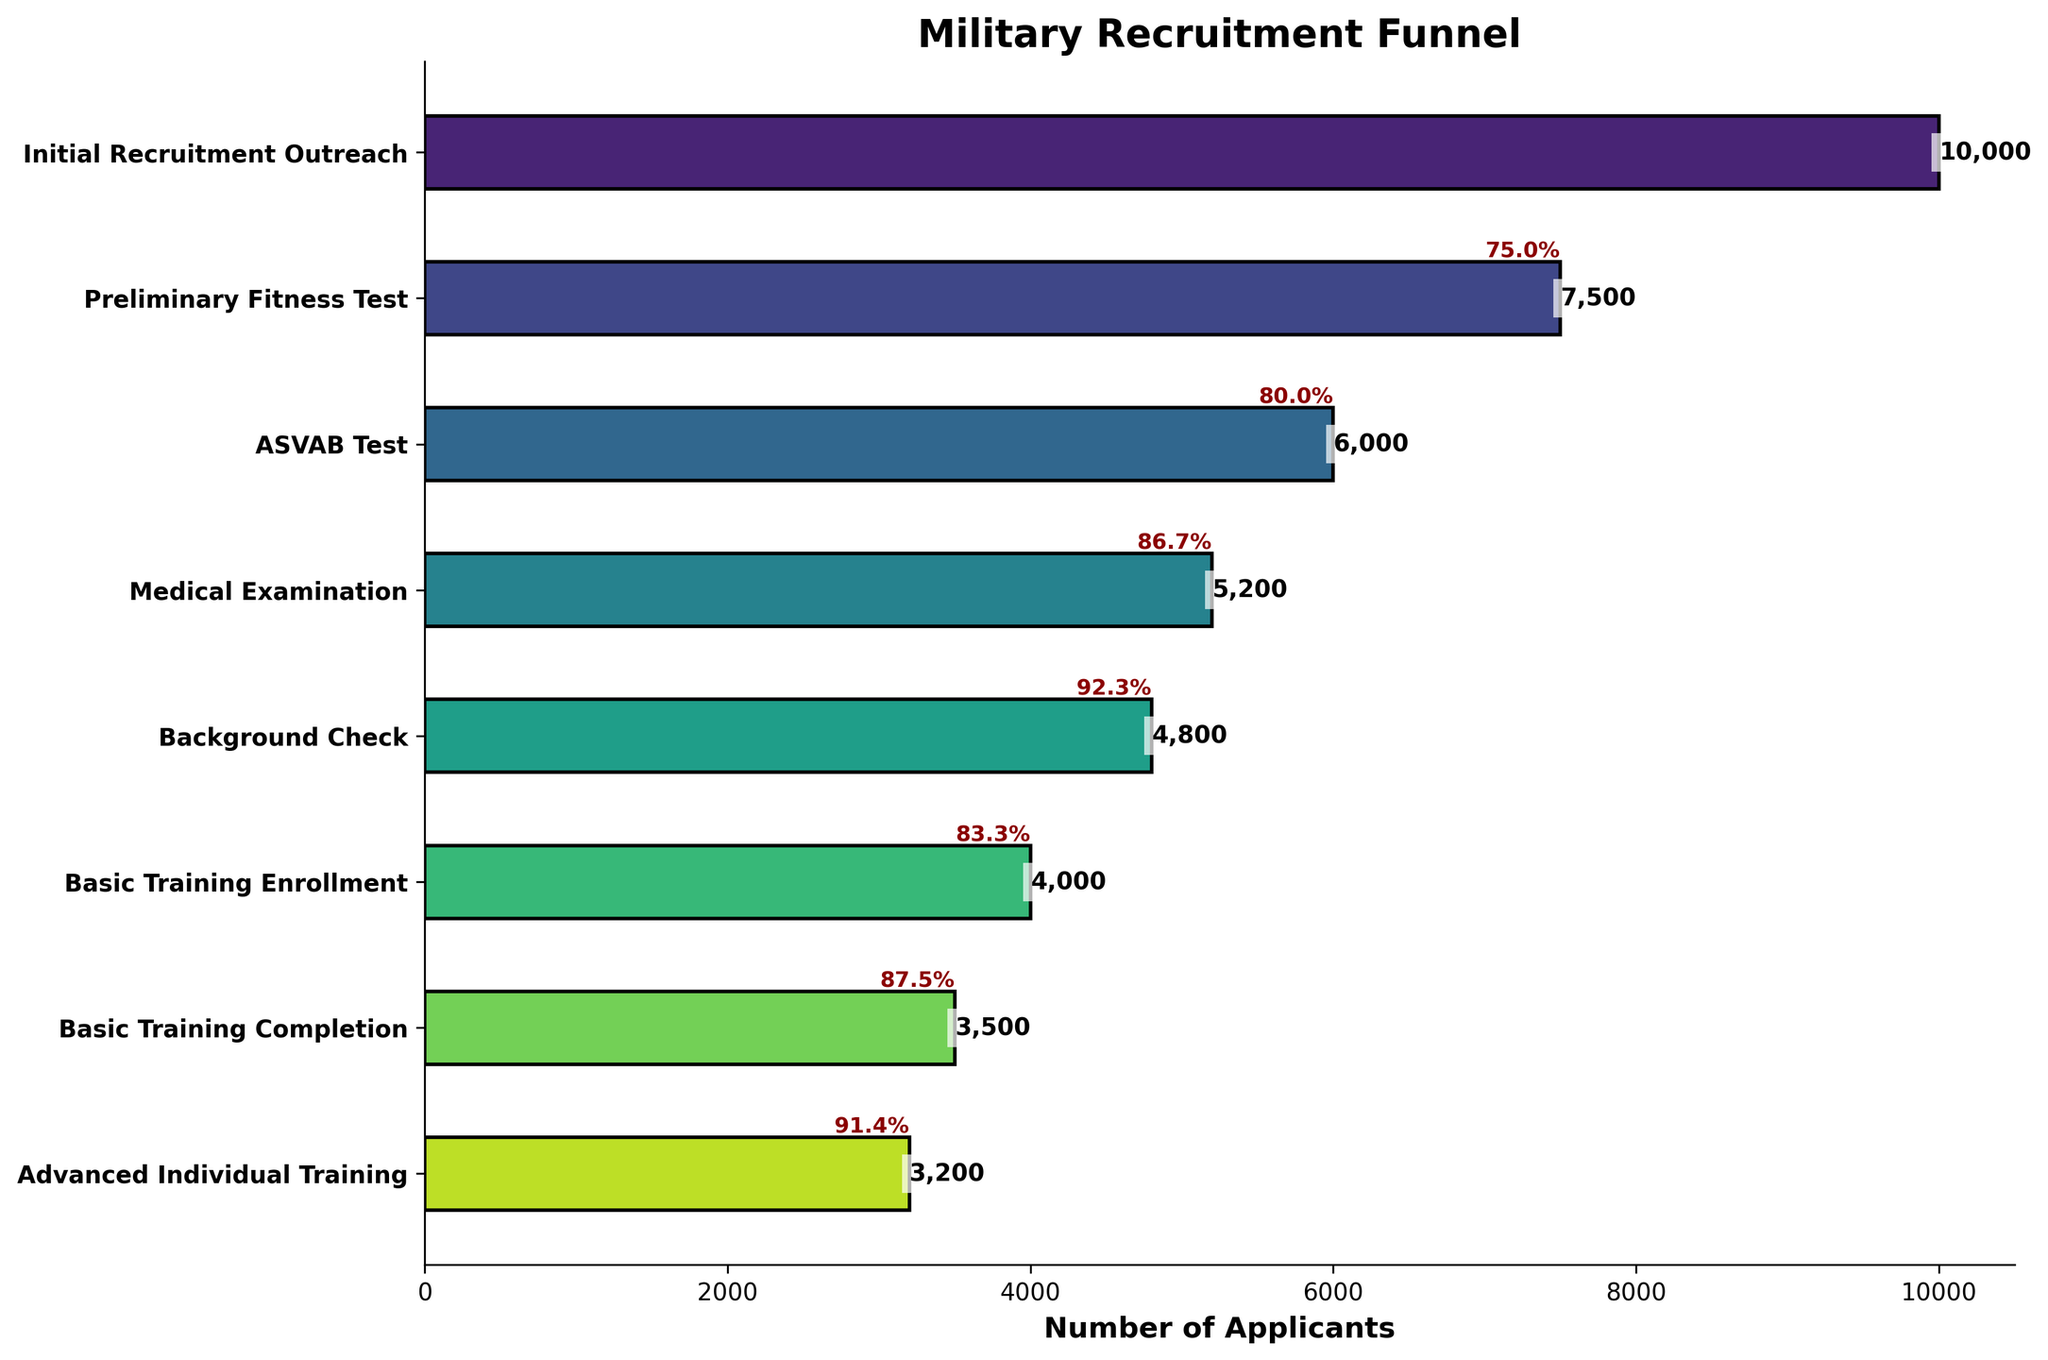What is the title of the chart? The title of the chart is typically found at the top and is often set in a larger or bold font. In this chart, it's "Military Recruitment Funnel."
Answer: Military Recruitment Funnel How many stages are represented in the funnel chart? The number of stages can be counted by the bars on the vertical axis of the chart. By counting each bar, we find there are 8 stages.
Answer: 8 What is the number of applicants at the Initial Recruitment Outreach stage? The number of applicants at each stage is displayed next to the bars. For the Initial Recruitment Outreach stage, the number is 10,000.
Answer: 10,000 How many applicants pass from the Medical Examination stage to the Background Check stage? The number of applicants who progress can be found by subtracting the Background Check stage count (4,800) from the Medical Examination stage count (5,200).
Answer: 400 Which stage has the lowest number of applicants? To find the stage with the lowest number of applicants, compare the numbers next to each bar. The Advanced Individual Training stage has the lowest at 3,200.
Answer: Advanced Individual Training What is the drop rate percentage between the Preliminary Fitness Test and the ASVAB Test stages? The drop rate is found by calculating the difference between the counts and then dividing by the initial count. \[((7500 - 6000)/7500) * 100 = 20\%
Answer: 20% By how much does the number of applicants decrease from Basic Training Enrollment to Basic Training Completion? Subtract the number at Basic Training Completion (3,500) from Basic Training Enrollment (4,000).
Answer: 500 What stage sees the largest drop in number of applicants? To find this, compare the differences between sequential stages. The stage from Preliminary Fitness Test (7,500) to ASVAB Test (6,000) has the largest drop of 1,500 applicants.
Answer: Preliminary Fitness Test to ASVAB Test What is the percentage of applicants that complete Basic Training compared to those who enroll in it? Calculate the ratio of Basic Training Completion (3,500) to Basic Training Enrollment (4,000) and multiply by 100. \((3,500/4,000) * 100 = 87.5\%
Answer: 87.5% How many applicants are lost from the start of the process to the end? Subtract the number of applicants in the final stage (Advanced Individual Training = 3,200) from the initial stage (Initial Recruitment Outreach = 10,000).
Answer: 6,800 